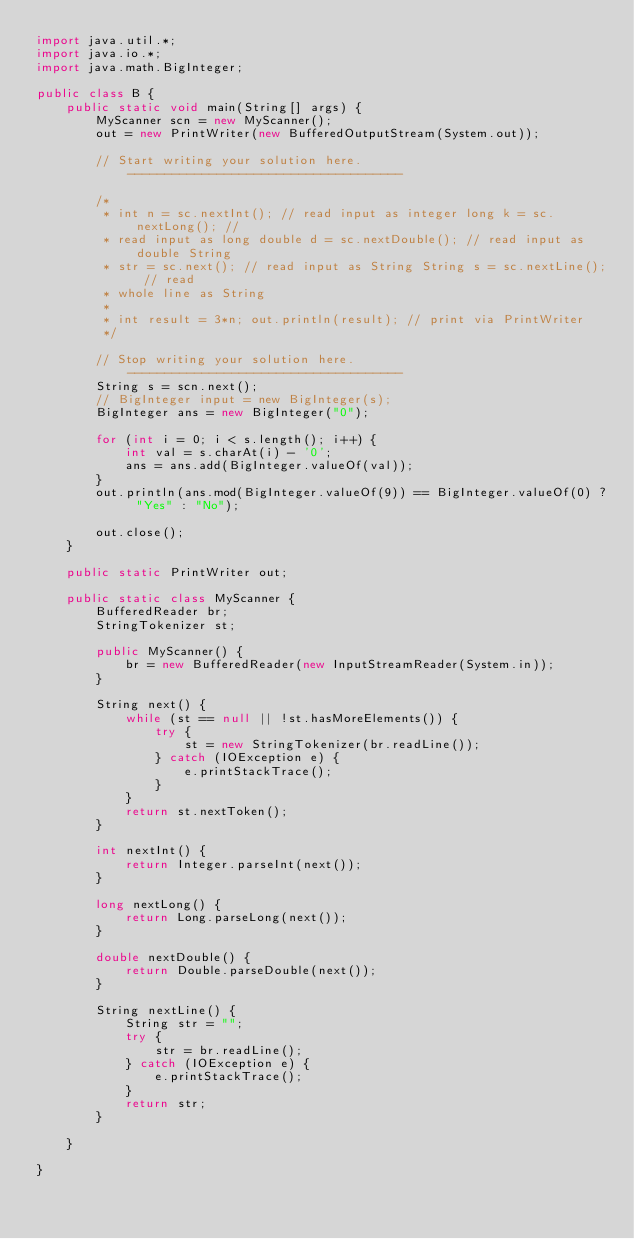<code> <loc_0><loc_0><loc_500><loc_500><_Java_>import java.util.*;
import java.io.*;
import java.math.BigInteger;

public class B {
    public static void main(String[] args) {
        MyScanner scn = new MyScanner();
        out = new PrintWriter(new BufferedOutputStream(System.out));

        // Start writing your solution here. -------------------------------------

        /*
         * int n = sc.nextInt(); // read input as integer long k = sc.nextLong(); //
         * read input as long double d = sc.nextDouble(); // read input as double String
         * str = sc.next(); // read input as String String s = sc.nextLine(); // read
         * whole line as String
         * 
         * int result = 3*n; out.println(result); // print via PrintWriter
         */

        // Stop writing your solution here. -------------------------------------
        String s = scn.next();
        // BigInteger input = new BigInteger(s);
        BigInteger ans = new BigInteger("0");

        for (int i = 0; i < s.length(); i++) {
            int val = s.charAt(i) - '0';
            ans = ans.add(BigInteger.valueOf(val));
        }
        out.println(ans.mod(BigInteger.valueOf(9)) == BigInteger.valueOf(0) ? "Yes" : "No");

        out.close();
    }

    public static PrintWriter out;

    public static class MyScanner {
        BufferedReader br;
        StringTokenizer st;

        public MyScanner() {
            br = new BufferedReader(new InputStreamReader(System.in));
        }

        String next() {
            while (st == null || !st.hasMoreElements()) {
                try {
                    st = new StringTokenizer(br.readLine());
                } catch (IOException e) {
                    e.printStackTrace();
                }
            }
            return st.nextToken();
        }

        int nextInt() {
            return Integer.parseInt(next());
        }

        long nextLong() {
            return Long.parseLong(next());
        }

        double nextDouble() {
            return Double.parseDouble(next());
        }

        String nextLine() {
            String str = "";
            try {
                str = br.readLine();
            } catch (IOException e) {
                e.printStackTrace();
            }
            return str;
        }

    }

}</code> 